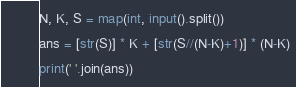<code> <loc_0><loc_0><loc_500><loc_500><_Python_>N, K, S = map(int, input().split())
ans = [str(S)] * K + [str(S//(N-K)+1)] * (N-K)
print(' '.join(ans))</code> 